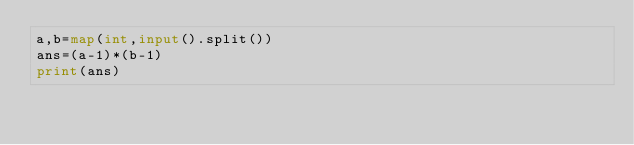<code> <loc_0><loc_0><loc_500><loc_500><_Python_>a,b=map(int,input().split())
ans=(a-1)*(b-1)
print(ans)</code> 